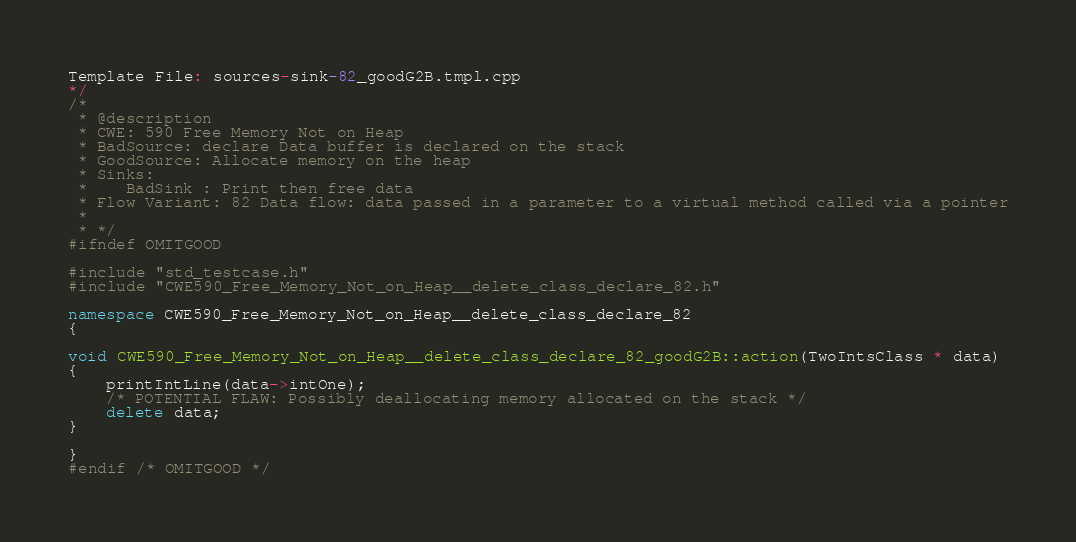<code> <loc_0><loc_0><loc_500><loc_500><_C++_>Template File: sources-sink-82_goodG2B.tmpl.cpp
*/
/*
 * @description
 * CWE: 590 Free Memory Not on Heap
 * BadSource: declare Data buffer is declared on the stack
 * GoodSource: Allocate memory on the heap
 * Sinks:
 *    BadSink : Print then free data
 * Flow Variant: 82 Data flow: data passed in a parameter to a virtual method called via a pointer
 *
 * */
#ifndef OMITGOOD

#include "std_testcase.h"
#include "CWE590_Free_Memory_Not_on_Heap__delete_class_declare_82.h"

namespace CWE590_Free_Memory_Not_on_Heap__delete_class_declare_82
{

void CWE590_Free_Memory_Not_on_Heap__delete_class_declare_82_goodG2B::action(TwoIntsClass * data)
{
    printIntLine(data->intOne);
    /* POTENTIAL FLAW: Possibly deallocating memory allocated on the stack */
    delete data;
}

}
#endif /* OMITGOOD */
</code> 